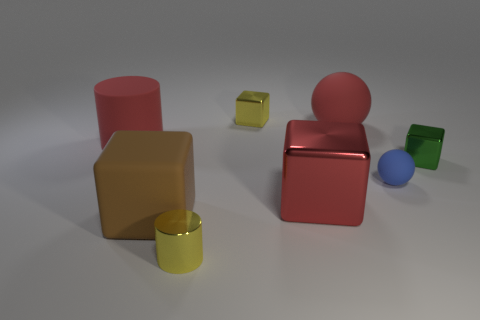Subtract all red metal cubes. How many cubes are left? 3 Add 1 metal cubes. How many objects exist? 9 Subtract all red balls. How many balls are left? 1 Subtract 1 cylinders. How many cylinders are left? 1 Subtract 0 yellow balls. How many objects are left? 8 Subtract all balls. How many objects are left? 6 Subtract all blue blocks. Subtract all blue cylinders. How many blocks are left? 4 Subtract all big brown blocks. Subtract all small blue metallic blocks. How many objects are left? 7 Add 4 red cylinders. How many red cylinders are left? 5 Add 2 red matte cylinders. How many red matte cylinders exist? 3 